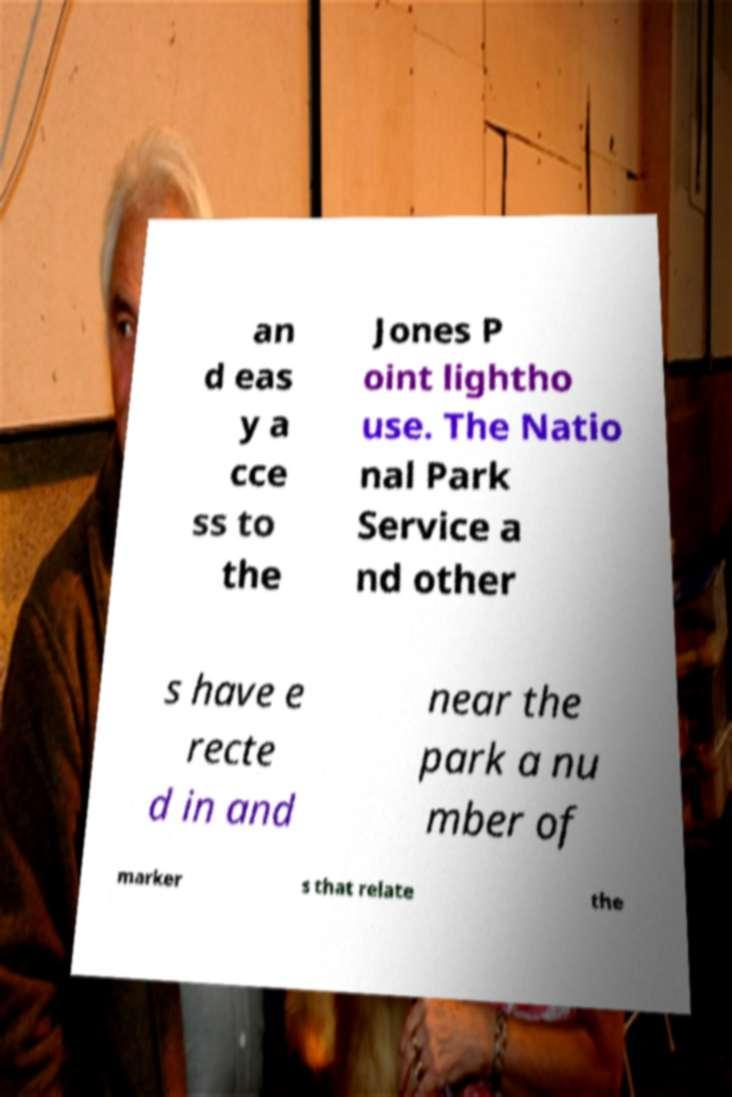Can you accurately transcribe the text from the provided image for me? an d eas y a cce ss to the Jones P oint lightho use. The Natio nal Park Service a nd other s have e recte d in and near the park a nu mber of marker s that relate the 